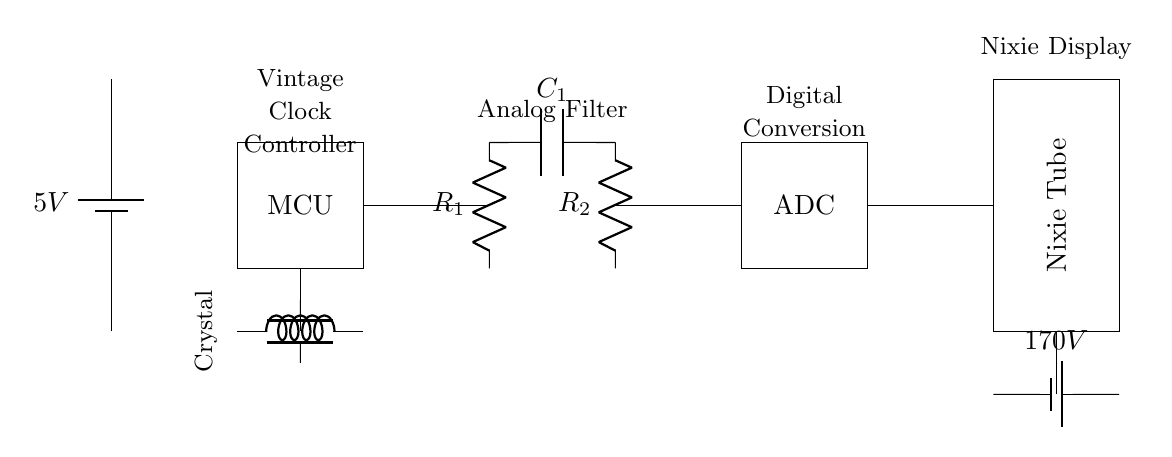What is the voltage of the battery supplying the circuit? The circuit is supplied by a 5V battery indicated at the top left. The label clearly states "5V".
Answer: 5V What component is responsible for converting the analog signal to digital? The circuit includes an Analog-to-Digital Converter (ADC), which is specifically designed for this purpose, as shown in the diagram.
Answer: ADC How many resistors are present in the analog section? The analog section contains two resistors labeled R1 and R2, as indicated in the circuit diagram.
Answer: 2 What is the voltage supply required for the nixie tube? The nixie tube requires a high voltage, specified in the diagram as 170V, which is listed next to the battery at the bottom right.
Answer: 170V What is the purpose of the crystal oscillator in this circuit? The crystal oscillator provides a stable clock signal to the microcontroller (MCU). The presence of both indicates a frequency source for timing functions.
Answer: Clock signal Which component connects the MCU and the analog section? The connection between the microcontroller and the analog section is made through a line that connects directly from the MCU to the first resistor, R1.
Answer: R1 